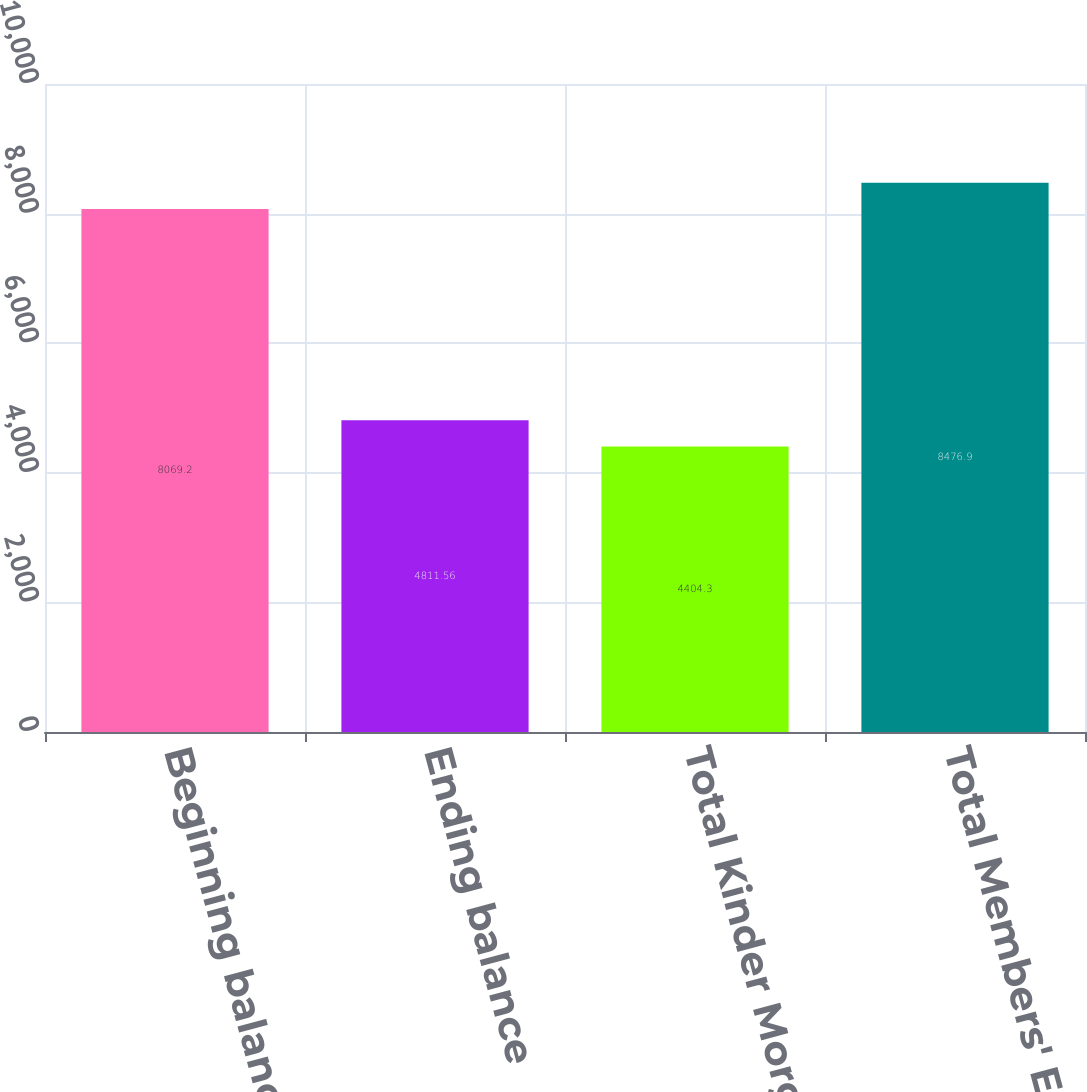Convert chart. <chart><loc_0><loc_0><loc_500><loc_500><bar_chart><fcel>Beginning balance<fcel>Ending balance<fcel>Total Kinder Morgan Inc's<fcel>Total Members' Equity<nl><fcel>8069.2<fcel>4811.56<fcel>4404.3<fcel>8476.9<nl></chart> 